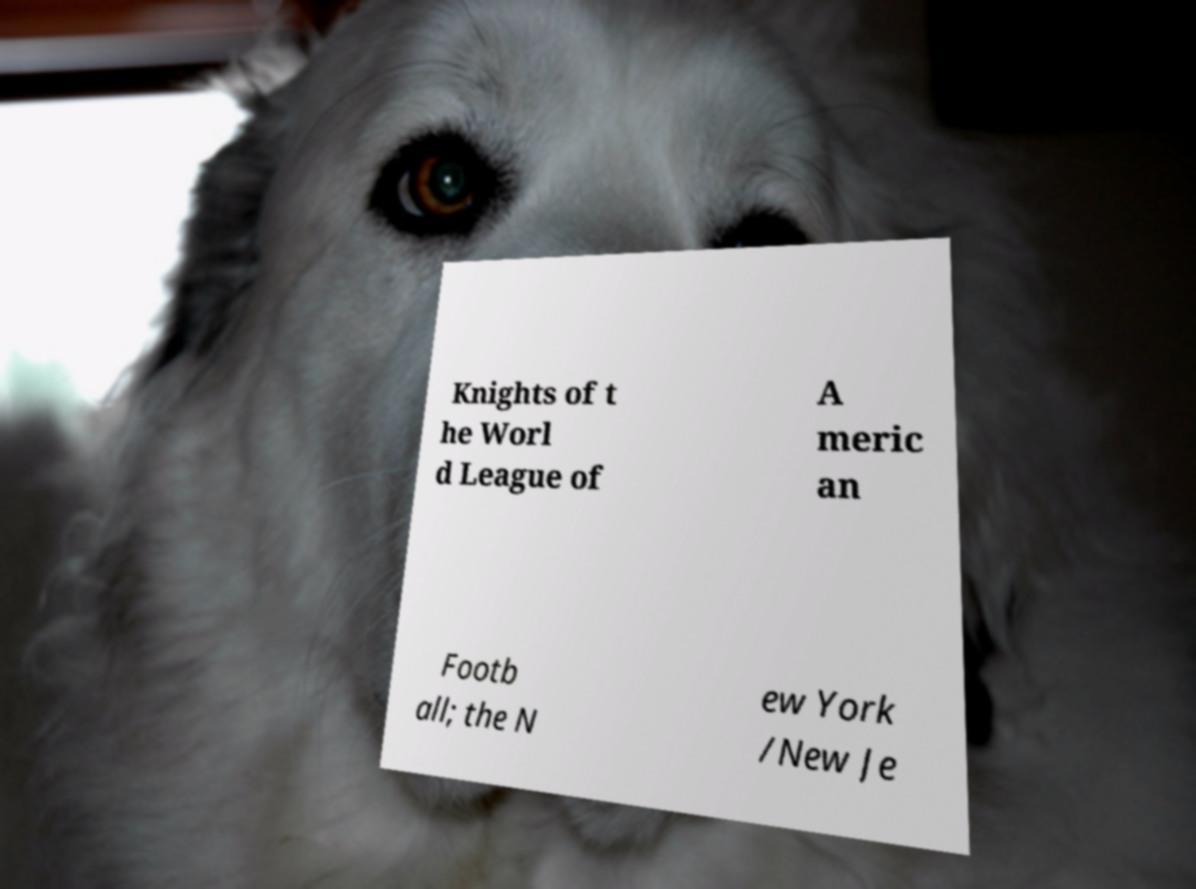There's text embedded in this image that I need extracted. Can you transcribe it verbatim? Knights of t he Worl d League of A meric an Footb all; the N ew York /New Je 